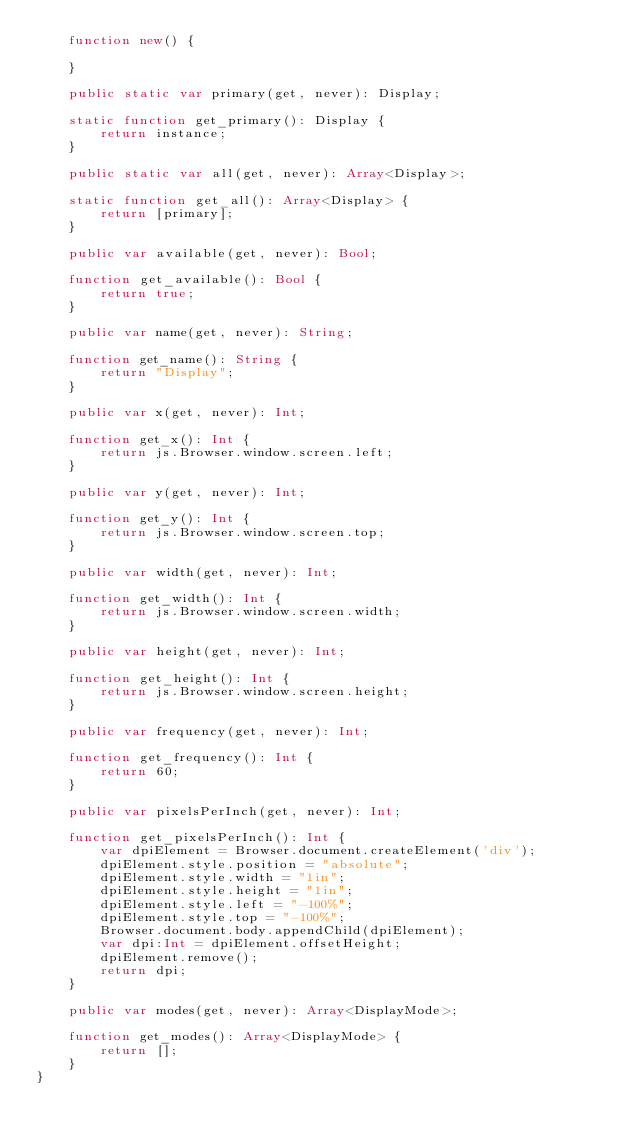<code> <loc_0><loc_0><loc_500><loc_500><_Haxe_>	function new() {

	}

	public static var primary(get, never): Display;

	static function get_primary(): Display {
		return instance;
	}

	public static var all(get, never): Array<Display>;

	static function get_all(): Array<Display> {
		return [primary];
	}

	public var available(get, never): Bool;

	function get_available(): Bool {
		return true;
	}

	public var name(get, never): String;

	function get_name(): String {
		return "Display";
	}

	public var x(get, never): Int;

	function get_x(): Int {
		return js.Browser.window.screen.left;
	}

	public var y(get, never): Int;

	function get_y(): Int {
		return js.Browser.window.screen.top;
	}

	public var width(get, never): Int;

	function get_width(): Int {
		return js.Browser.window.screen.width;
	}

	public var height(get, never): Int;

	function get_height(): Int {
		return js.Browser.window.screen.height;
	}

	public var frequency(get, never): Int;

	function get_frequency(): Int {
		return 60;
	}

	public var pixelsPerInch(get, never): Int;

	function get_pixelsPerInch(): Int {
		var dpiElement = Browser.document.createElement('div');
		dpiElement.style.position = "absolute";
		dpiElement.style.width = "1in";
		dpiElement.style.height = "1in";
		dpiElement.style.left = "-100%";
		dpiElement.style.top = "-100%";
		Browser.document.body.appendChild(dpiElement);
		var dpi:Int = dpiElement.offsetHeight;
		dpiElement.remove();
		return dpi;
	}

	public var modes(get, never): Array<DisplayMode>;

	function get_modes(): Array<DisplayMode> {
		return [];
	}
}
</code> 